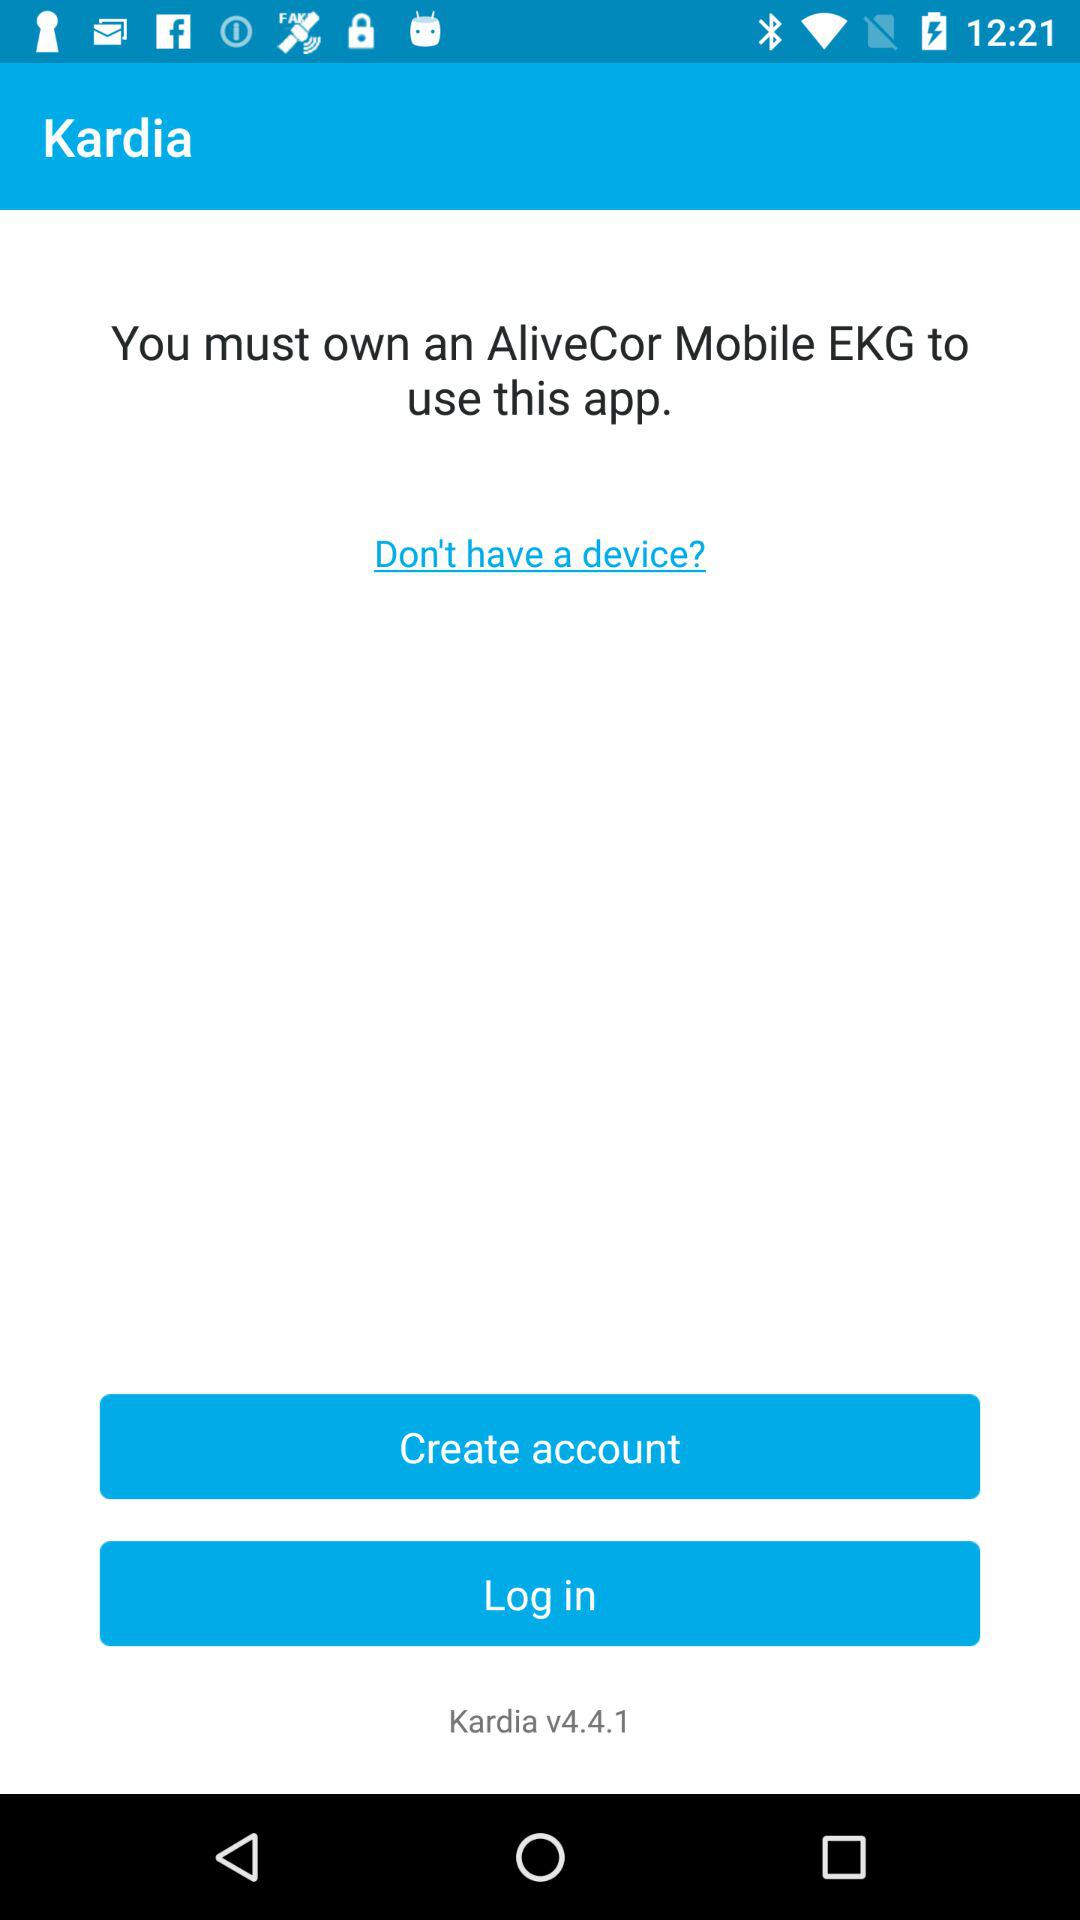How long does it take to log in?
When the provided information is insufficient, respond with <no answer>. <no answer> 